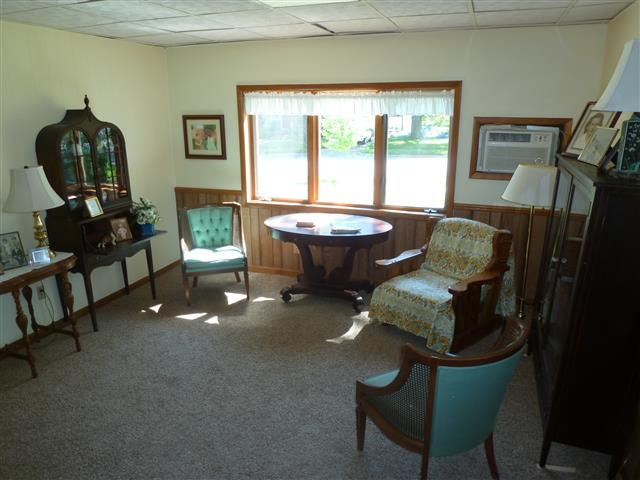Describe the objects in this image and their specific colors. I can see chair in gray, black, and teal tones, chair in gray, black, darkgreen, and darkgray tones, dining table in gray, black, and white tones, chair in gray, teal, and white tones, and potted plant in gray, black, and navy tones in this image. 